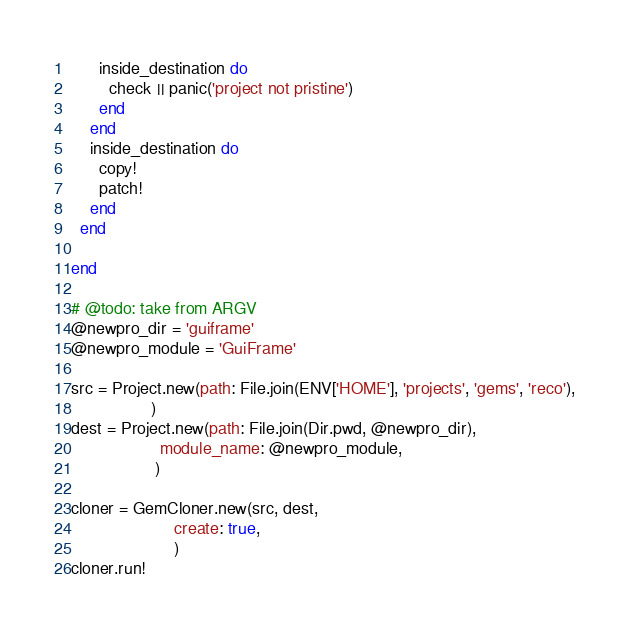Convert code to text. <code><loc_0><loc_0><loc_500><loc_500><_Ruby_>      inside_destination do
        check || panic('project not pristine')
      end
    end
    inside_destination do
      copy!
      patch!
    end
  end

end

# @todo: take from ARGV
@newpro_dir = 'guiframe'
@newpro_module = 'GuiFrame'

src = Project.new(path: File.join(ENV['HOME'], 'projects', 'gems', 'reco'),
                 )
dest = Project.new(path: File.join(Dir.pwd, @newpro_dir),
                   module_name: @newpro_module,
                  )

cloner = GemCloner.new(src, dest,
                      create: true,
                      )
cloner.run!




</code> 